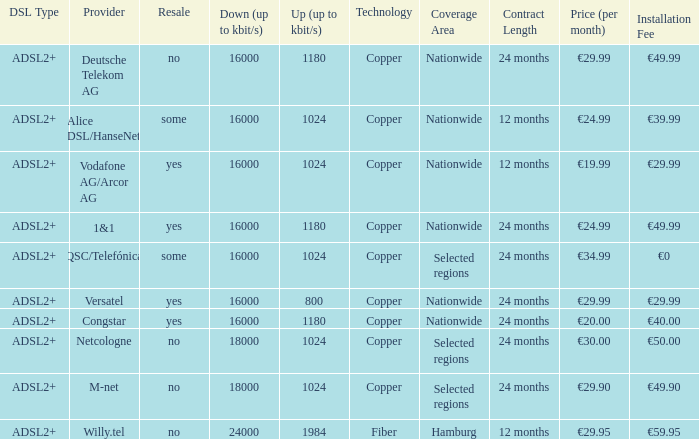Who are all of the telecom providers for which the upload rate is 1024 kbits and the resale category is yes? Vodafone AG/Arcor AG. 